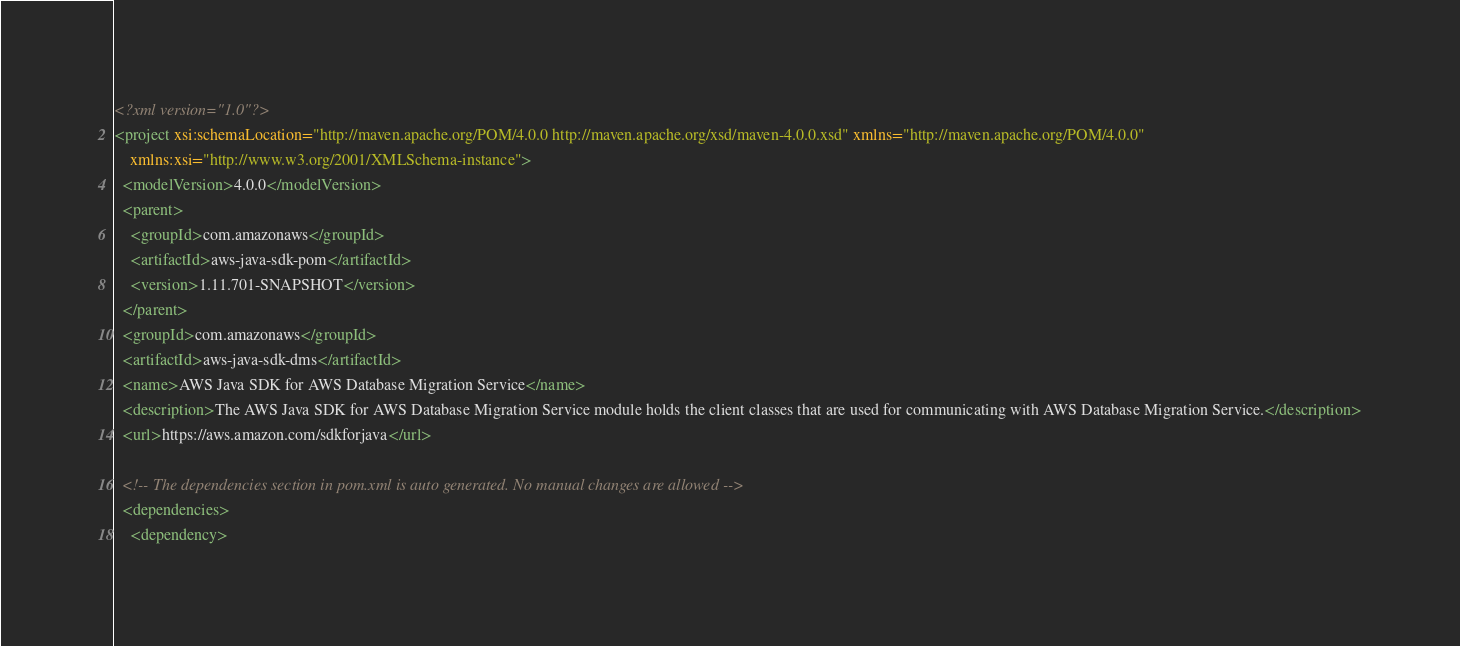Convert code to text. <code><loc_0><loc_0><loc_500><loc_500><_XML_><?xml version="1.0"?>
<project xsi:schemaLocation="http://maven.apache.org/POM/4.0.0 http://maven.apache.org/xsd/maven-4.0.0.xsd" xmlns="http://maven.apache.org/POM/4.0.0"
    xmlns:xsi="http://www.w3.org/2001/XMLSchema-instance">
  <modelVersion>4.0.0</modelVersion>
  <parent>
    <groupId>com.amazonaws</groupId>
    <artifactId>aws-java-sdk-pom</artifactId>
    <version>1.11.701-SNAPSHOT</version>
  </parent>
  <groupId>com.amazonaws</groupId>
  <artifactId>aws-java-sdk-dms</artifactId>
  <name>AWS Java SDK for AWS Database Migration Service</name>
  <description>The AWS Java SDK for AWS Database Migration Service module holds the client classes that are used for communicating with AWS Database Migration Service.</description>
  <url>https://aws.amazon.com/sdkforjava</url>

  <!-- The dependencies section in pom.xml is auto generated. No manual changes are allowed -->
  <dependencies>
    <dependency></code> 